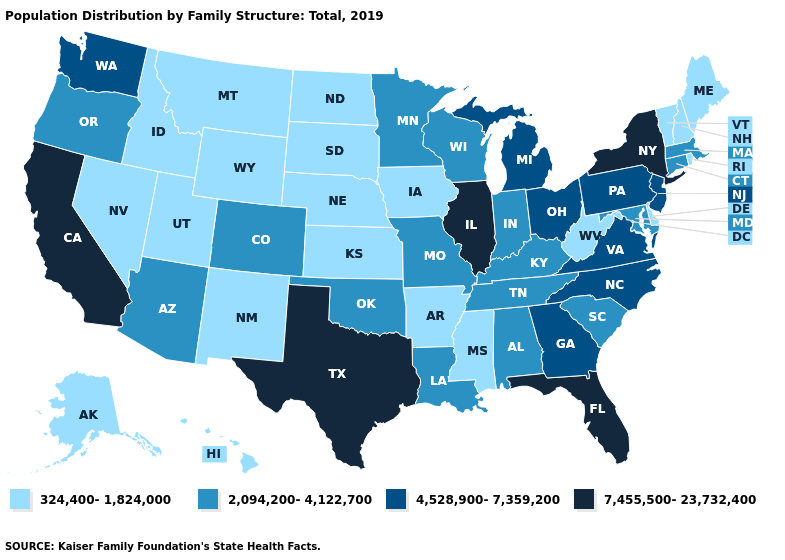What is the lowest value in the Northeast?
Write a very short answer. 324,400-1,824,000. What is the value of New Jersey?
Give a very brief answer. 4,528,900-7,359,200. Among the states that border Idaho , does Wyoming have the highest value?
Keep it brief. No. Name the states that have a value in the range 7,455,500-23,732,400?
Short answer required. California, Florida, Illinois, New York, Texas. Does Wisconsin have the lowest value in the MidWest?
Write a very short answer. No. What is the value of Ohio?
Concise answer only. 4,528,900-7,359,200. Among the states that border Florida , does Alabama have the highest value?
Quick response, please. No. Which states have the highest value in the USA?
Give a very brief answer. California, Florida, Illinois, New York, Texas. What is the highest value in states that border Utah?
Short answer required. 2,094,200-4,122,700. Name the states that have a value in the range 4,528,900-7,359,200?
Short answer required. Georgia, Michigan, New Jersey, North Carolina, Ohio, Pennsylvania, Virginia, Washington. Among the states that border Maryland , does West Virginia have the lowest value?
Write a very short answer. Yes. How many symbols are there in the legend?
Answer briefly. 4. Among the states that border Washington , which have the lowest value?
Keep it brief. Idaho. Name the states that have a value in the range 2,094,200-4,122,700?
Quick response, please. Alabama, Arizona, Colorado, Connecticut, Indiana, Kentucky, Louisiana, Maryland, Massachusetts, Minnesota, Missouri, Oklahoma, Oregon, South Carolina, Tennessee, Wisconsin. What is the highest value in the West ?
Write a very short answer. 7,455,500-23,732,400. 